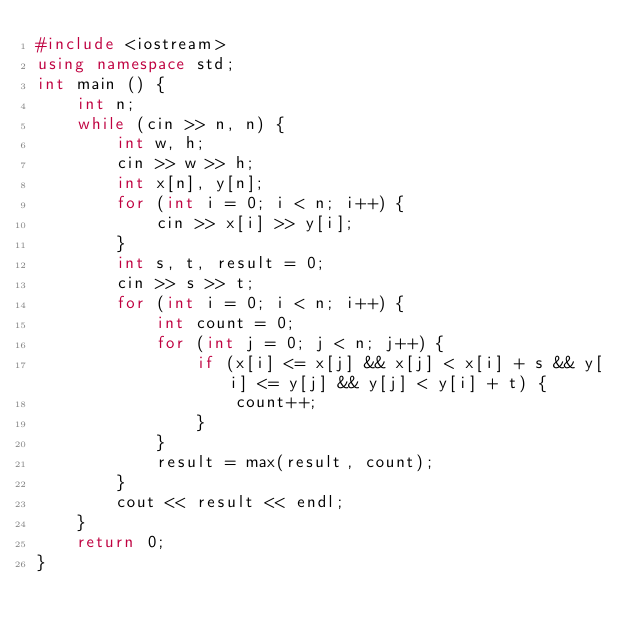<code> <loc_0><loc_0><loc_500><loc_500><_C++_>#include <iostream>
using namespace std;
int main () {
	int n;
	while (cin >> n, n) {
		int w, h;
		cin >> w >> h;
		int x[n], y[n];
		for (int i = 0; i < n; i++) {
			cin >> x[i] >> y[i];
		}
		int s, t, result = 0;
		cin >> s >> t;
		for (int i = 0; i < n; i++) {
			int count = 0;
			for (int j = 0; j < n; j++) {
				if (x[i] <= x[j] && x[j] < x[i] + s && y[i] <= y[j] && y[j] < y[i] + t) {
					count++;
				}
			}
			result = max(result, count);
		}
		cout << result << endl;
	}
	return 0;
}</code> 